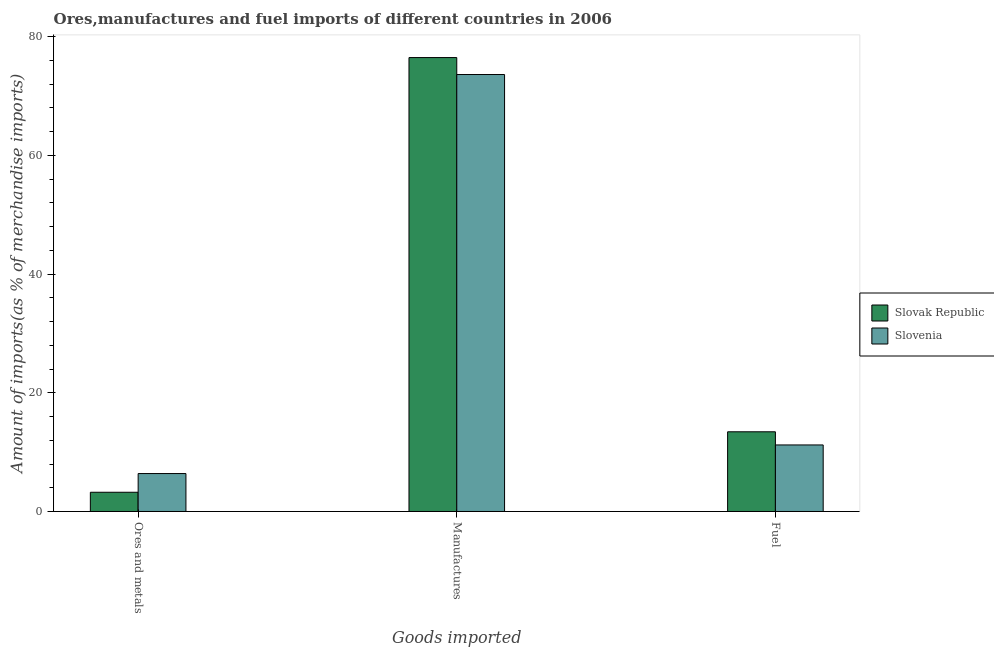Are the number of bars on each tick of the X-axis equal?
Make the answer very short. Yes. How many bars are there on the 3rd tick from the right?
Your answer should be compact. 2. What is the label of the 1st group of bars from the left?
Provide a succinct answer. Ores and metals. What is the percentage of manufactures imports in Slovak Republic?
Give a very brief answer. 76.49. Across all countries, what is the maximum percentage of ores and metals imports?
Provide a short and direct response. 6.39. Across all countries, what is the minimum percentage of manufactures imports?
Provide a short and direct response. 73.63. In which country was the percentage of fuel imports maximum?
Your response must be concise. Slovak Republic. In which country was the percentage of ores and metals imports minimum?
Provide a succinct answer. Slovak Republic. What is the total percentage of fuel imports in the graph?
Offer a very short reply. 24.64. What is the difference between the percentage of ores and metals imports in Slovak Republic and that in Slovenia?
Offer a terse response. -3.15. What is the difference between the percentage of manufactures imports in Slovak Republic and the percentage of ores and metals imports in Slovenia?
Make the answer very short. 70.1. What is the average percentage of fuel imports per country?
Offer a very short reply. 12.32. What is the difference between the percentage of manufactures imports and percentage of fuel imports in Slovenia?
Offer a very short reply. 62.42. In how many countries, is the percentage of manufactures imports greater than 36 %?
Provide a succinct answer. 2. What is the ratio of the percentage of ores and metals imports in Slovak Republic to that in Slovenia?
Keep it short and to the point. 0.51. Is the percentage of fuel imports in Slovak Republic less than that in Slovenia?
Keep it short and to the point. No. Is the difference between the percentage of manufactures imports in Slovenia and Slovak Republic greater than the difference between the percentage of fuel imports in Slovenia and Slovak Republic?
Your answer should be compact. No. What is the difference between the highest and the second highest percentage of ores and metals imports?
Your response must be concise. 3.15. What is the difference between the highest and the lowest percentage of manufactures imports?
Offer a terse response. 2.86. In how many countries, is the percentage of ores and metals imports greater than the average percentage of ores and metals imports taken over all countries?
Provide a short and direct response. 1. What does the 2nd bar from the left in Manufactures represents?
Your answer should be compact. Slovenia. What does the 2nd bar from the right in Manufactures represents?
Give a very brief answer. Slovak Republic. What is the difference between two consecutive major ticks on the Y-axis?
Your answer should be very brief. 20. Does the graph contain any zero values?
Offer a terse response. No. Does the graph contain grids?
Provide a succinct answer. No. How many legend labels are there?
Ensure brevity in your answer.  2. What is the title of the graph?
Your response must be concise. Ores,manufactures and fuel imports of different countries in 2006. Does "Cuba" appear as one of the legend labels in the graph?
Your response must be concise. No. What is the label or title of the X-axis?
Ensure brevity in your answer.  Goods imported. What is the label or title of the Y-axis?
Your response must be concise. Amount of imports(as % of merchandise imports). What is the Amount of imports(as % of merchandise imports) of Slovak Republic in Ores and metals?
Give a very brief answer. 3.24. What is the Amount of imports(as % of merchandise imports) of Slovenia in Ores and metals?
Ensure brevity in your answer.  6.39. What is the Amount of imports(as % of merchandise imports) of Slovak Republic in Manufactures?
Provide a succinct answer. 76.49. What is the Amount of imports(as % of merchandise imports) in Slovenia in Manufactures?
Your answer should be compact. 73.63. What is the Amount of imports(as % of merchandise imports) of Slovak Republic in Fuel?
Offer a very short reply. 13.43. What is the Amount of imports(as % of merchandise imports) in Slovenia in Fuel?
Offer a very short reply. 11.21. Across all Goods imported, what is the maximum Amount of imports(as % of merchandise imports) in Slovak Republic?
Make the answer very short. 76.49. Across all Goods imported, what is the maximum Amount of imports(as % of merchandise imports) in Slovenia?
Your answer should be very brief. 73.63. Across all Goods imported, what is the minimum Amount of imports(as % of merchandise imports) in Slovak Republic?
Keep it short and to the point. 3.24. Across all Goods imported, what is the minimum Amount of imports(as % of merchandise imports) in Slovenia?
Give a very brief answer. 6.39. What is the total Amount of imports(as % of merchandise imports) of Slovak Republic in the graph?
Give a very brief answer. 93.16. What is the total Amount of imports(as % of merchandise imports) of Slovenia in the graph?
Keep it short and to the point. 91.24. What is the difference between the Amount of imports(as % of merchandise imports) in Slovak Republic in Ores and metals and that in Manufactures?
Your answer should be very brief. -73.25. What is the difference between the Amount of imports(as % of merchandise imports) of Slovenia in Ores and metals and that in Manufactures?
Make the answer very short. -67.24. What is the difference between the Amount of imports(as % of merchandise imports) of Slovak Republic in Ores and metals and that in Fuel?
Offer a terse response. -10.19. What is the difference between the Amount of imports(as % of merchandise imports) in Slovenia in Ores and metals and that in Fuel?
Your answer should be compact. -4.82. What is the difference between the Amount of imports(as % of merchandise imports) in Slovak Republic in Manufactures and that in Fuel?
Your answer should be very brief. 63.06. What is the difference between the Amount of imports(as % of merchandise imports) in Slovenia in Manufactures and that in Fuel?
Your answer should be compact. 62.42. What is the difference between the Amount of imports(as % of merchandise imports) in Slovak Republic in Ores and metals and the Amount of imports(as % of merchandise imports) in Slovenia in Manufactures?
Provide a succinct answer. -70.39. What is the difference between the Amount of imports(as % of merchandise imports) of Slovak Republic in Ores and metals and the Amount of imports(as % of merchandise imports) of Slovenia in Fuel?
Make the answer very short. -7.97. What is the difference between the Amount of imports(as % of merchandise imports) of Slovak Republic in Manufactures and the Amount of imports(as % of merchandise imports) of Slovenia in Fuel?
Keep it short and to the point. 65.28. What is the average Amount of imports(as % of merchandise imports) in Slovak Republic per Goods imported?
Provide a succinct answer. 31.05. What is the average Amount of imports(as % of merchandise imports) in Slovenia per Goods imported?
Keep it short and to the point. 30.41. What is the difference between the Amount of imports(as % of merchandise imports) of Slovak Republic and Amount of imports(as % of merchandise imports) of Slovenia in Ores and metals?
Offer a terse response. -3.15. What is the difference between the Amount of imports(as % of merchandise imports) of Slovak Republic and Amount of imports(as % of merchandise imports) of Slovenia in Manufactures?
Keep it short and to the point. 2.86. What is the difference between the Amount of imports(as % of merchandise imports) in Slovak Republic and Amount of imports(as % of merchandise imports) in Slovenia in Fuel?
Provide a succinct answer. 2.22. What is the ratio of the Amount of imports(as % of merchandise imports) of Slovak Republic in Ores and metals to that in Manufactures?
Offer a very short reply. 0.04. What is the ratio of the Amount of imports(as % of merchandise imports) in Slovenia in Ores and metals to that in Manufactures?
Your response must be concise. 0.09. What is the ratio of the Amount of imports(as % of merchandise imports) in Slovak Republic in Ores and metals to that in Fuel?
Make the answer very short. 0.24. What is the ratio of the Amount of imports(as % of merchandise imports) of Slovenia in Ores and metals to that in Fuel?
Your answer should be very brief. 0.57. What is the ratio of the Amount of imports(as % of merchandise imports) in Slovak Republic in Manufactures to that in Fuel?
Offer a very short reply. 5.7. What is the ratio of the Amount of imports(as % of merchandise imports) of Slovenia in Manufactures to that in Fuel?
Provide a succinct answer. 6.57. What is the difference between the highest and the second highest Amount of imports(as % of merchandise imports) in Slovak Republic?
Your answer should be very brief. 63.06. What is the difference between the highest and the second highest Amount of imports(as % of merchandise imports) of Slovenia?
Your response must be concise. 62.42. What is the difference between the highest and the lowest Amount of imports(as % of merchandise imports) of Slovak Republic?
Offer a very short reply. 73.25. What is the difference between the highest and the lowest Amount of imports(as % of merchandise imports) of Slovenia?
Offer a very short reply. 67.24. 